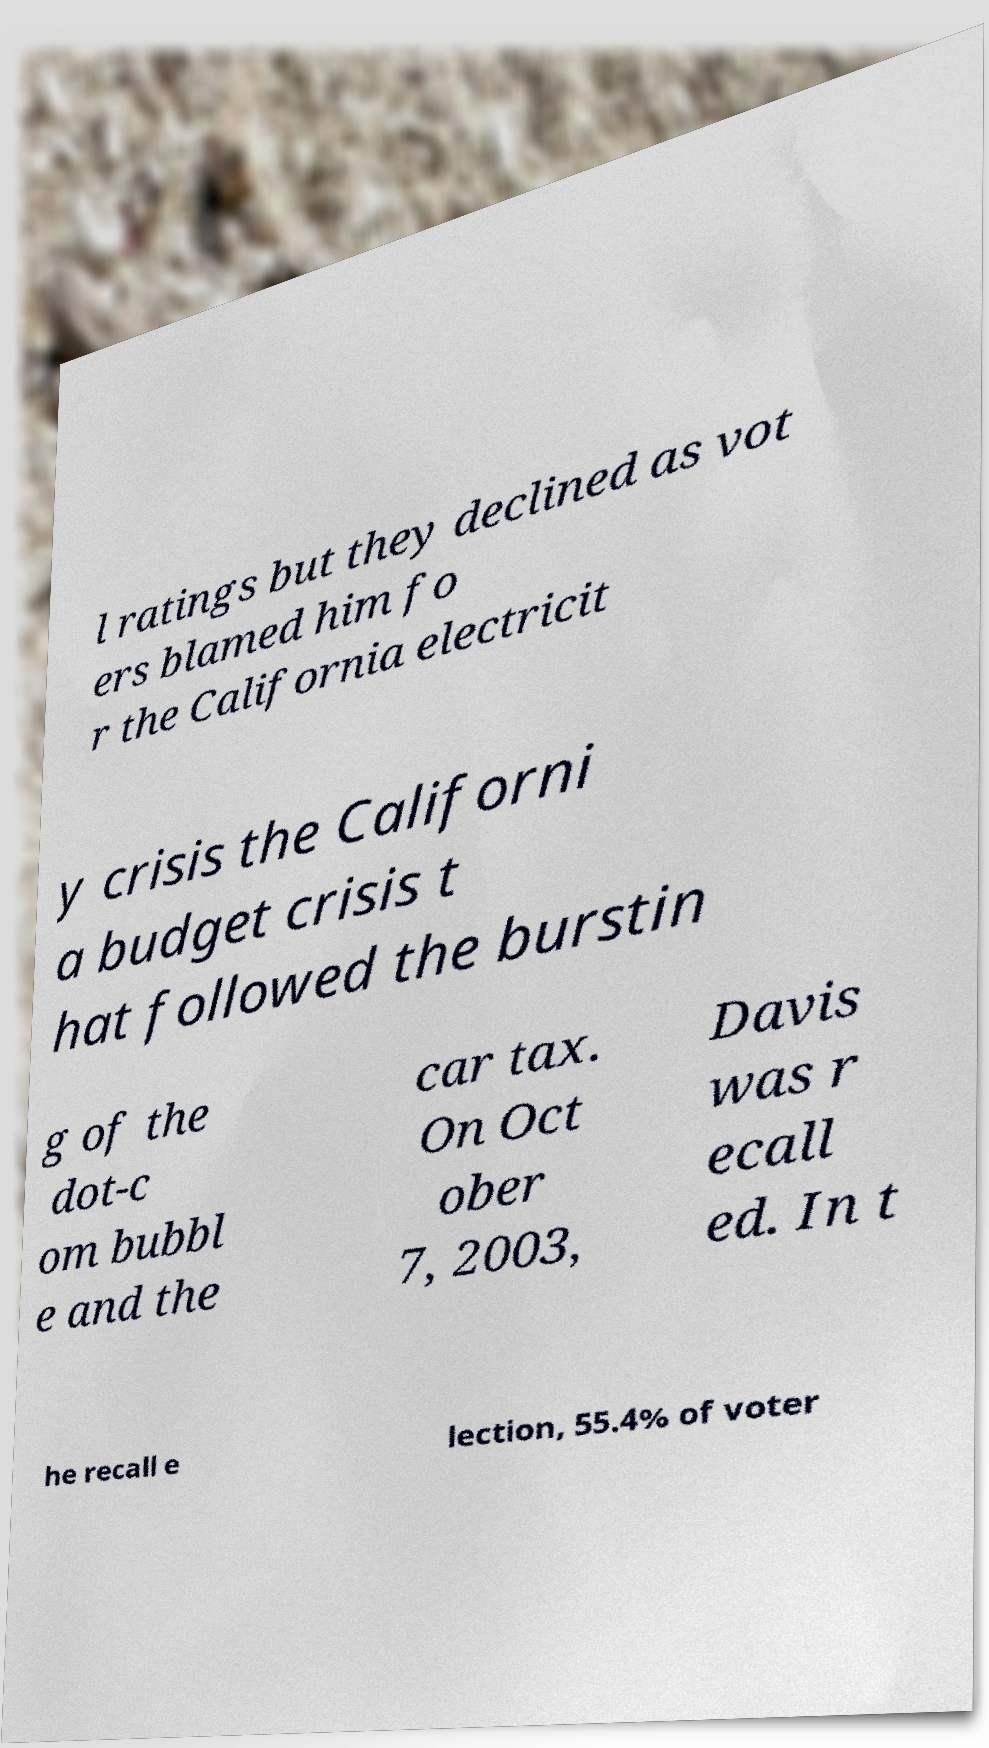Please identify and transcribe the text found in this image. l ratings but they declined as vot ers blamed him fo r the California electricit y crisis the Californi a budget crisis t hat followed the burstin g of the dot-c om bubbl e and the car tax. On Oct ober 7, 2003, Davis was r ecall ed. In t he recall e lection, 55.4% of voter 